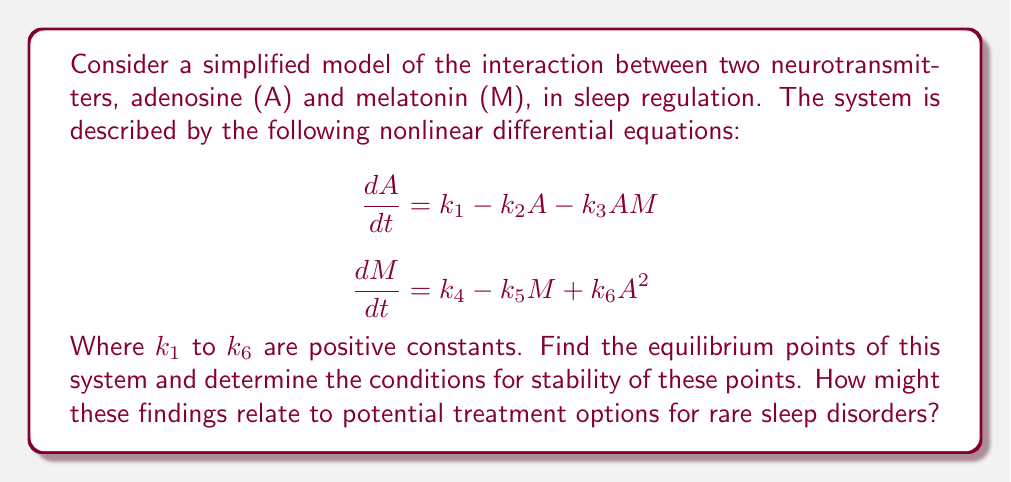Can you answer this question? 1) To find the equilibrium points, set both equations to zero:

   $$k_1 - k_2A - k_3AM = 0 \quad (1)$$
   $$k_4 - k_5M + k_6A^2 = 0 \quad (2)$$

2) From equation (2), express M in terms of A:

   $$M = \frac{k_4 + k_6A^2}{k_5} \quad (3)$$

3) Substitute (3) into (1):

   $$k_1 - k_2A - k_3A(\frac{k_4 + k_6A^2}{k_5}) = 0$$

4) Simplify:

   $$k_1k_5 - k_2k_5A - k_3k_4A - k_3k_6A^3 = 0$$

5) This is a cubic equation in A. Depending on the values of the constants, it can have one or three real roots. Each root A* corresponds to an equilibrium point (A*, M*).

6) To determine stability, we need to evaluate the Jacobian matrix at each equilibrium point:

   $$J = \begin{bmatrix} 
   -k_2 - k_3M & -k_3A \\
   2k_6A & -k_5
   \end{bmatrix}$$

7) For stability, the eigenvalues of J should have negative real parts. This occurs when:

   $$\text{tr}(J) < 0 \quad \text{and} \quad \det(J) > 0$$

   Where tr(J) is the trace and det(J) is the determinant of J.

8) These conditions translate to:

   $$-k_2 - k_3M - k_5 < 0 \quad \text{and} \quad k_2k_5 + k_3k_5M - 2k_3k_6A^2 > 0$$

9) The stability of each equilibrium point can be determined by substituting its coordinates into these inequalities.

10) For treatment options, stable equilibrium points represent potential steady states of neurotransmitter levels. Unstable points might indicate thresholds between different sleep states. Manipulating the rate constants (k1 to k6) through medication or other interventions could shift the system towards more favorable equilibrium points, potentially improving sleep regulation in rare disorders.
Answer: Equilibrium points: Roots of $k_1k_5 - k_2k_5A - k_3k_4A - k_3k_6A^3 = 0$. Stability conditions: $-k_2 - k_3M - k_5 < 0$ and $k_2k_5 + k_3k_5M - 2k_3k_6A^2 > 0$. 